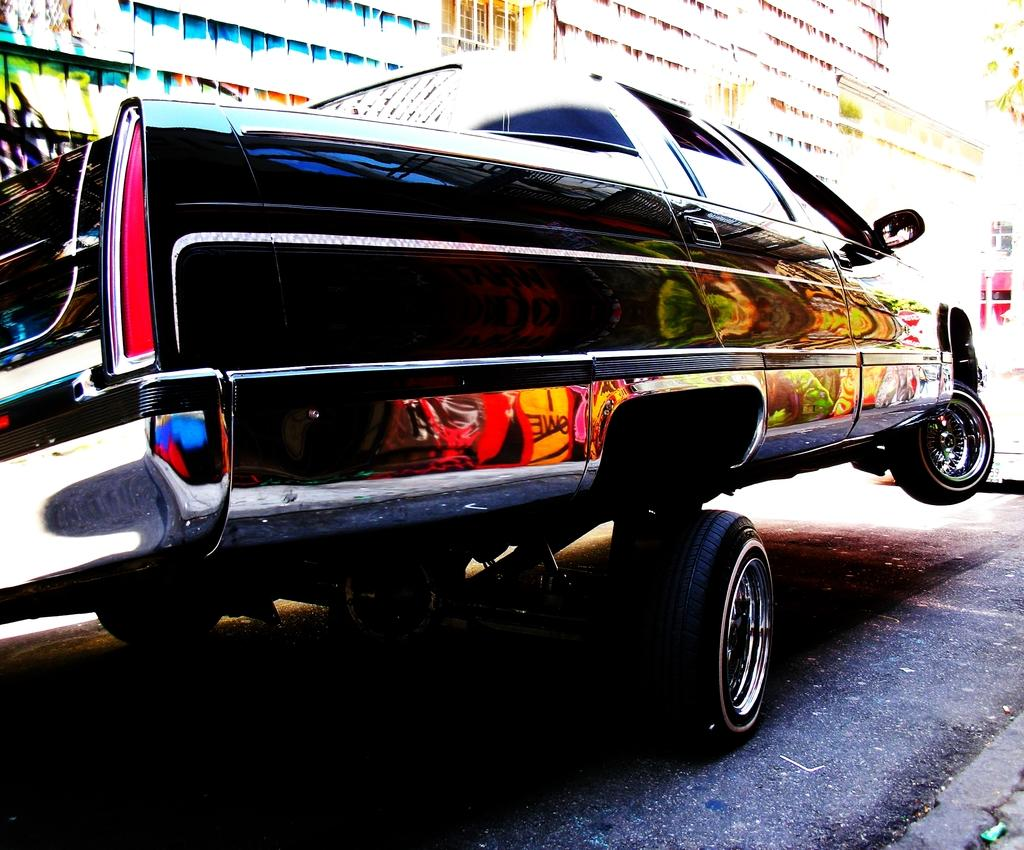What is the main subject of the image? There is a vehicle in the image. Where is the vehicle located? The vehicle is on the road. What can be seen in the background of the image? There are buildings and trees in the background of the image. How many houses are visible in the image? There is no mention of houses in the image; only buildings are mentioned. Can you tell me the name of the girl standing next to the vehicle? There is no girl present in the image. 